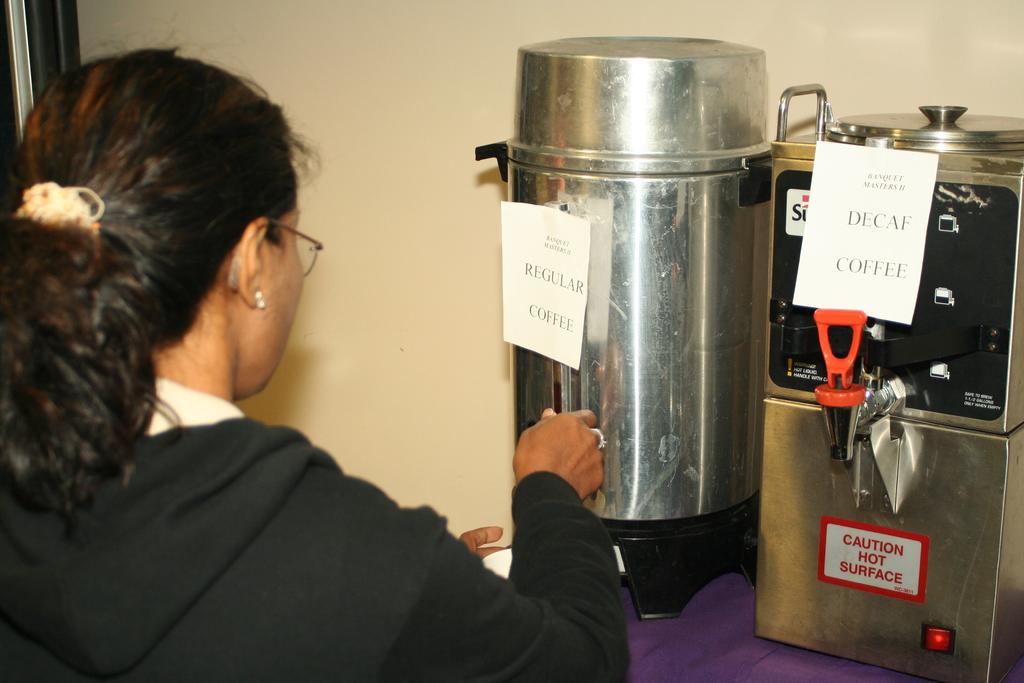What kind of coffee is on the right?
Make the answer very short. Decaf. How does the dispenser feel if touched?
Give a very brief answer. Hot. 